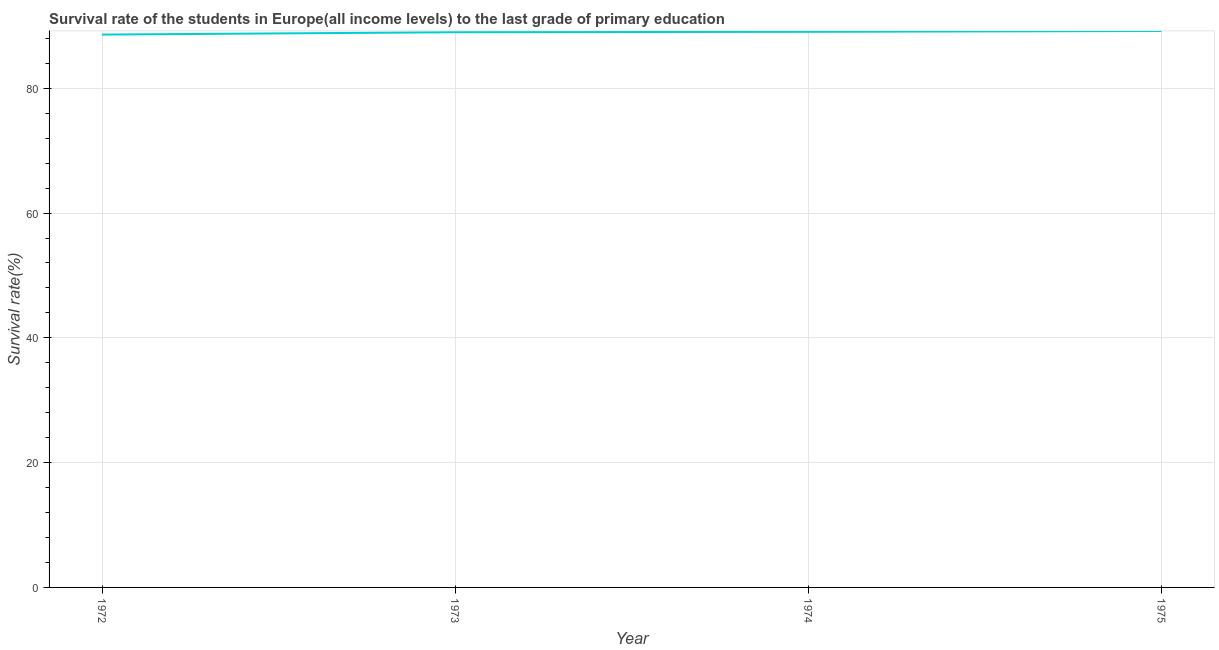What is the survival rate in primary education in 1973?
Make the answer very short. 88.98. Across all years, what is the maximum survival rate in primary education?
Ensure brevity in your answer.  89.18. Across all years, what is the minimum survival rate in primary education?
Provide a succinct answer. 88.61. In which year was the survival rate in primary education maximum?
Make the answer very short. 1975. What is the sum of the survival rate in primary education?
Your answer should be compact. 355.82. What is the difference between the survival rate in primary education in 1972 and 1975?
Your answer should be very brief. -0.57. What is the average survival rate in primary education per year?
Your answer should be compact. 88.95. What is the median survival rate in primary education?
Ensure brevity in your answer.  89.01. In how many years, is the survival rate in primary education greater than 76 %?
Give a very brief answer. 4. Do a majority of the years between 1975 and 1972 (inclusive) have survival rate in primary education greater than 60 %?
Keep it short and to the point. Yes. What is the ratio of the survival rate in primary education in 1973 to that in 1975?
Provide a short and direct response. 1. Is the difference between the survival rate in primary education in 1972 and 1974 greater than the difference between any two years?
Give a very brief answer. No. What is the difference between the highest and the second highest survival rate in primary education?
Give a very brief answer. 0.13. Is the sum of the survival rate in primary education in 1972 and 1974 greater than the maximum survival rate in primary education across all years?
Provide a short and direct response. Yes. What is the difference between the highest and the lowest survival rate in primary education?
Make the answer very short. 0.57. Does the survival rate in primary education monotonically increase over the years?
Make the answer very short. Yes. How many years are there in the graph?
Provide a succinct answer. 4. What is the difference between two consecutive major ticks on the Y-axis?
Ensure brevity in your answer.  20. Does the graph contain grids?
Provide a short and direct response. Yes. What is the title of the graph?
Give a very brief answer. Survival rate of the students in Europe(all income levels) to the last grade of primary education. What is the label or title of the X-axis?
Give a very brief answer. Year. What is the label or title of the Y-axis?
Your response must be concise. Survival rate(%). What is the Survival rate(%) of 1972?
Keep it short and to the point. 88.61. What is the Survival rate(%) in 1973?
Your answer should be compact. 88.98. What is the Survival rate(%) of 1974?
Give a very brief answer. 89.05. What is the Survival rate(%) of 1975?
Your answer should be very brief. 89.18. What is the difference between the Survival rate(%) in 1972 and 1973?
Make the answer very short. -0.37. What is the difference between the Survival rate(%) in 1972 and 1974?
Your answer should be very brief. -0.44. What is the difference between the Survival rate(%) in 1972 and 1975?
Give a very brief answer. -0.57. What is the difference between the Survival rate(%) in 1973 and 1974?
Your answer should be very brief. -0.07. What is the difference between the Survival rate(%) in 1973 and 1975?
Ensure brevity in your answer.  -0.2. What is the difference between the Survival rate(%) in 1974 and 1975?
Offer a very short reply. -0.13. What is the ratio of the Survival rate(%) in 1972 to that in 1974?
Give a very brief answer. 0.99. What is the ratio of the Survival rate(%) in 1972 to that in 1975?
Your answer should be compact. 0.99. What is the ratio of the Survival rate(%) in 1973 to that in 1975?
Give a very brief answer. 1. 